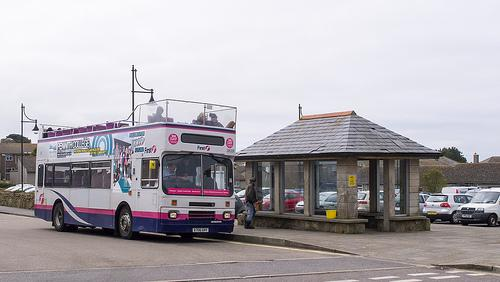Question: who is on the sidewalk?
Choices:
A. A woman.
B. A kid.
C. A retiree.
D. A man.
Answer with the letter. Answer: D Question: what color is the bus?
Choices:
A. Black.
B. Orange.
C. White.
D. Red.
Answer with the letter. Answer: C Question: why is it so bright?
Choices:
A. Sunny.
B. Nice day.
C. No showers.
D. Daylight.
Answer with the letter. Answer: A 